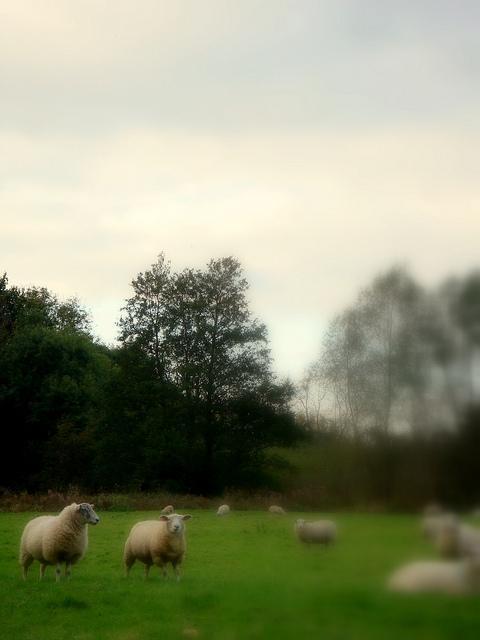How many kids are there?
Give a very brief answer. 0. How many sheep are there?
Give a very brief answer. 4. How many horses in the photo?
Give a very brief answer. 0. 